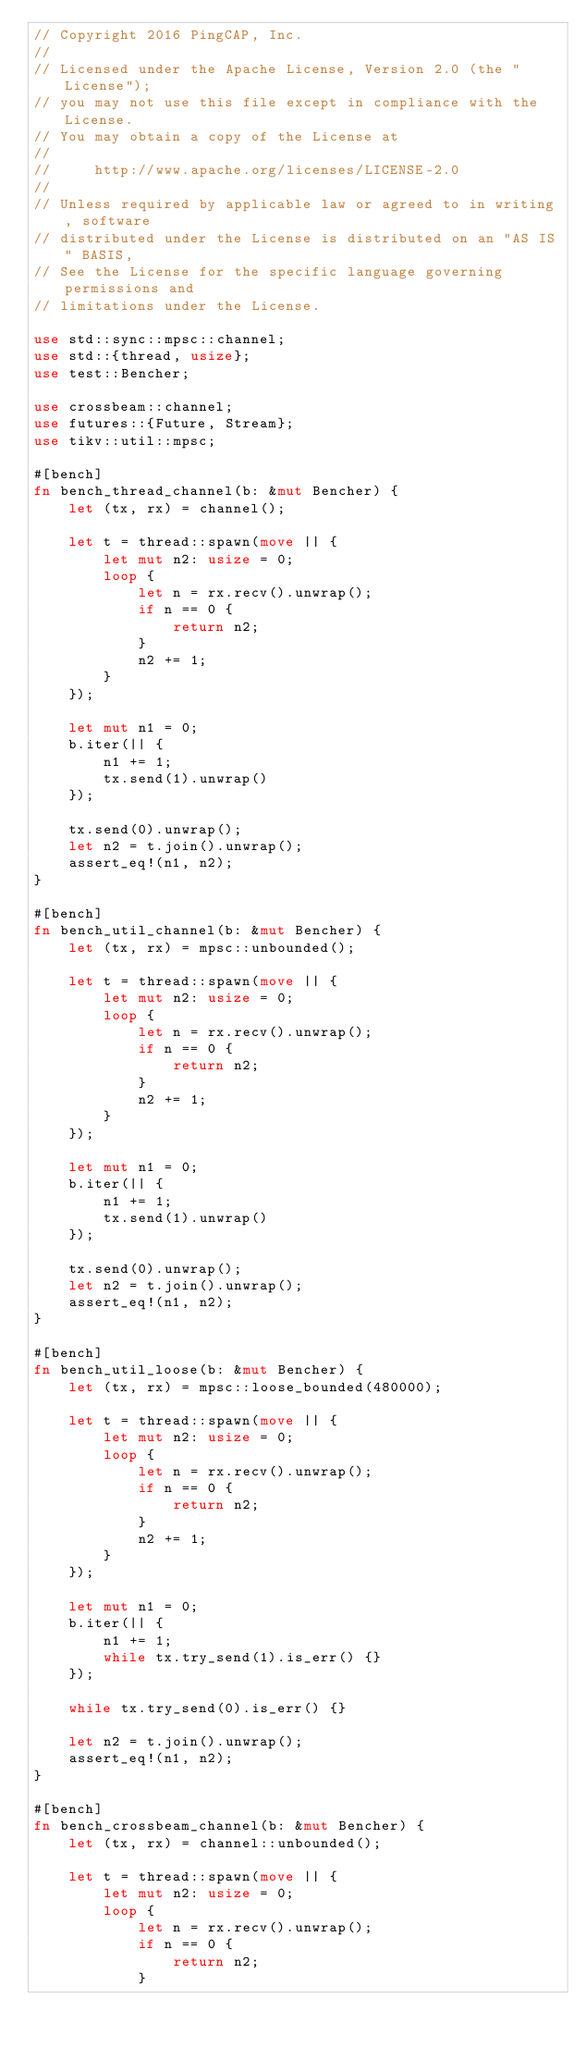Convert code to text. <code><loc_0><loc_0><loc_500><loc_500><_Rust_>// Copyright 2016 PingCAP, Inc.
//
// Licensed under the Apache License, Version 2.0 (the "License");
// you may not use this file except in compliance with the License.
// You may obtain a copy of the License at
//
//     http://www.apache.org/licenses/LICENSE-2.0
//
// Unless required by applicable law or agreed to in writing, software
// distributed under the License is distributed on an "AS IS" BASIS,
// See the License for the specific language governing permissions and
// limitations under the License.

use std::sync::mpsc::channel;
use std::{thread, usize};
use test::Bencher;

use crossbeam::channel;
use futures::{Future, Stream};
use tikv::util::mpsc;

#[bench]
fn bench_thread_channel(b: &mut Bencher) {
    let (tx, rx) = channel();

    let t = thread::spawn(move || {
        let mut n2: usize = 0;
        loop {
            let n = rx.recv().unwrap();
            if n == 0 {
                return n2;
            }
            n2 += 1;
        }
    });

    let mut n1 = 0;
    b.iter(|| {
        n1 += 1;
        tx.send(1).unwrap()
    });

    tx.send(0).unwrap();
    let n2 = t.join().unwrap();
    assert_eq!(n1, n2);
}

#[bench]
fn bench_util_channel(b: &mut Bencher) {
    let (tx, rx) = mpsc::unbounded();

    let t = thread::spawn(move || {
        let mut n2: usize = 0;
        loop {
            let n = rx.recv().unwrap();
            if n == 0 {
                return n2;
            }
            n2 += 1;
        }
    });

    let mut n1 = 0;
    b.iter(|| {
        n1 += 1;
        tx.send(1).unwrap()
    });

    tx.send(0).unwrap();
    let n2 = t.join().unwrap();
    assert_eq!(n1, n2);
}

#[bench]
fn bench_util_loose(b: &mut Bencher) {
    let (tx, rx) = mpsc::loose_bounded(480000);

    let t = thread::spawn(move || {
        let mut n2: usize = 0;
        loop {
            let n = rx.recv().unwrap();
            if n == 0 {
                return n2;
            }
            n2 += 1;
        }
    });

    let mut n1 = 0;
    b.iter(|| {
        n1 += 1;
        while tx.try_send(1).is_err() {}
    });

    while tx.try_send(0).is_err() {}

    let n2 = t.join().unwrap();
    assert_eq!(n1, n2);
}

#[bench]
fn bench_crossbeam_channel(b: &mut Bencher) {
    let (tx, rx) = channel::unbounded();

    let t = thread::spawn(move || {
        let mut n2: usize = 0;
        loop {
            let n = rx.recv().unwrap();
            if n == 0 {
                return n2;
            }</code> 